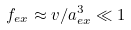Convert formula to latex. <formula><loc_0><loc_0><loc_500><loc_500>f _ { e x } \approx v / a _ { e x } ^ { 3 } \ll 1</formula> 